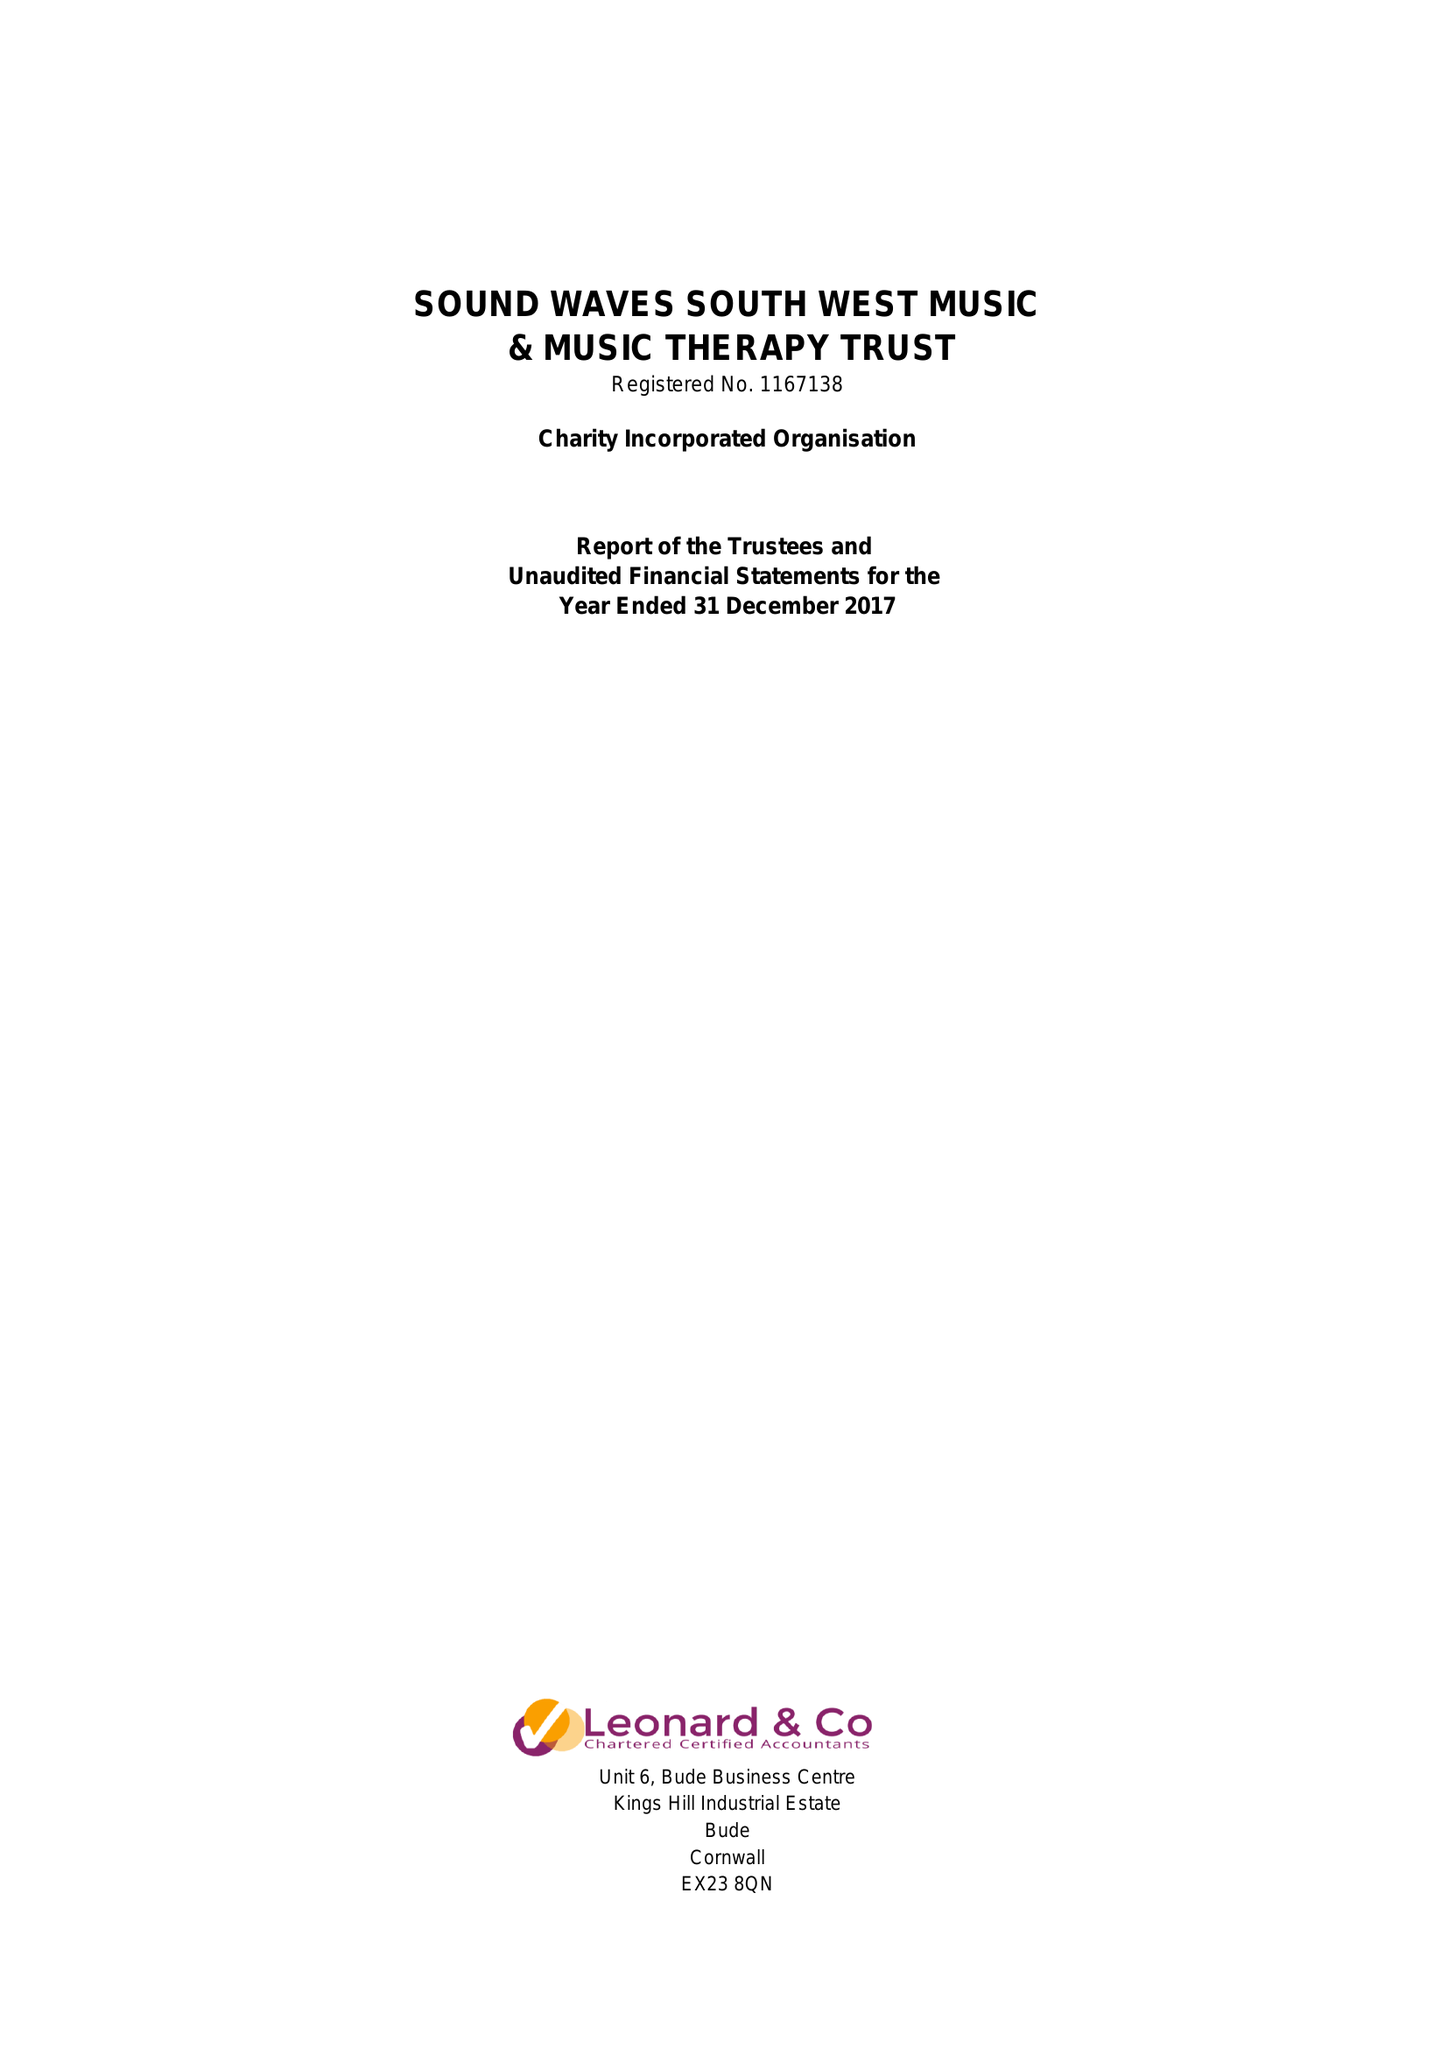What is the value for the address__postcode?
Answer the question using a single word or phrase. EX23 9JN 